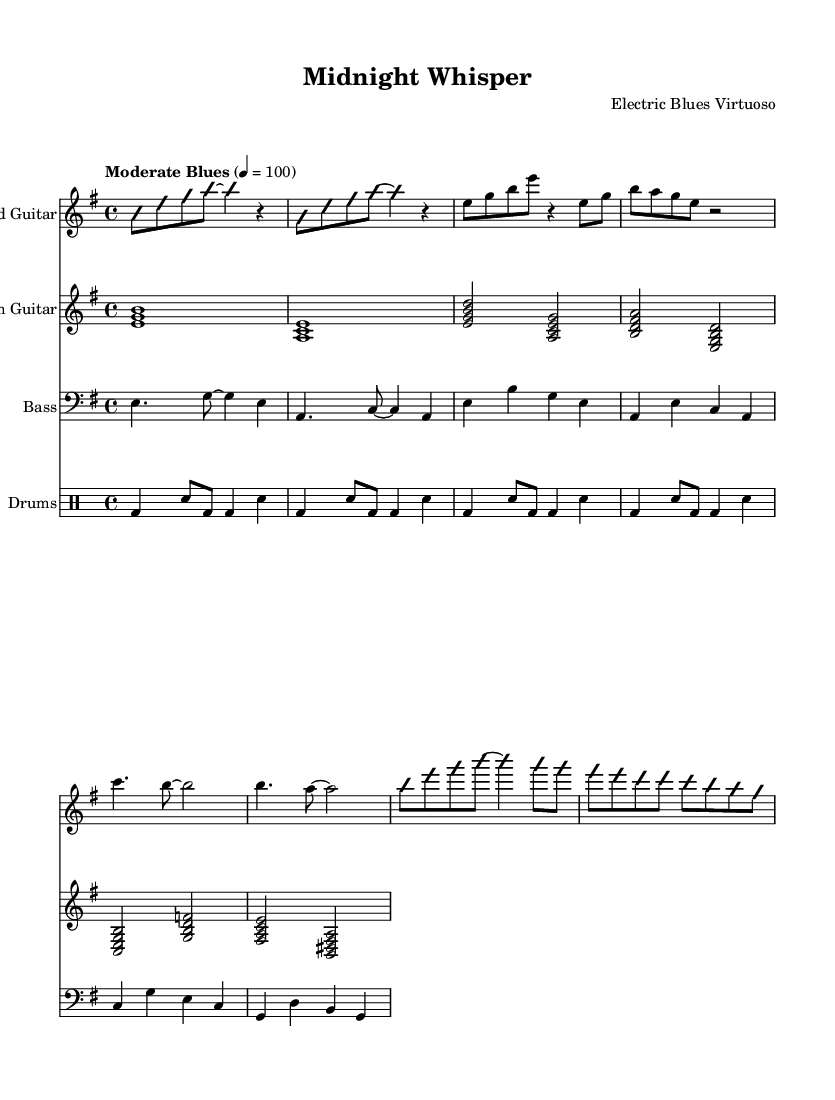What is the key signature of this music? The key signature is indicated at the beginning of the music. In this case, it is E minor, which has one sharp (F#).
Answer: E minor What is the time signature of this music? The time signature is found at the beginning, indicating how many beats are in each measure. Here, it is 4/4, meaning there are four beats per measure.
Answer: 4/4 What is the tempo indication provided in the sheet music? The tempo is marked in the beginning section of the music. It is indicated as "Moderate Blues," which suggests a moderate speed of 100 beats per minute.
Answer: Moderate Blues How many measures are in the introduction? To determine the number of measures in the introduction, we count the measures listed before the verse starts. There are a total of 2 measures in the introduction section.
Answer: 2 What is the chord played in the rhythm guitar during the intro? The rhythm guitar plays an explicit chord in the introduction. The first chord is an E major chord, represented by the notes E, G, and B.
Answer: E major chord What genre does this piece of music belong to? The genre is characterized by its style and instrumentation, which includes electric guitars and a blues structure. This piece clearly fits into the Electric Blues genre.
Answer: Electric Blues Which instrument is primarily featured in the solo section? In the provided sheet music, the lead guitar is the instrument that takes the lead during the solo section, consisting of improvisational elements.
Answer: Lead Guitar 